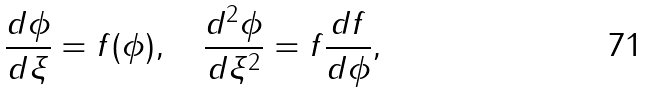<formula> <loc_0><loc_0><loc_500><loc_500>\frac { d \phi } { d \xi } = f ( \phi ) , \quad \frac { d ^ { 2 } \phi } { d \xi ^ { 2 } } = f \frac { d f } { d \phi } ,</formula> 